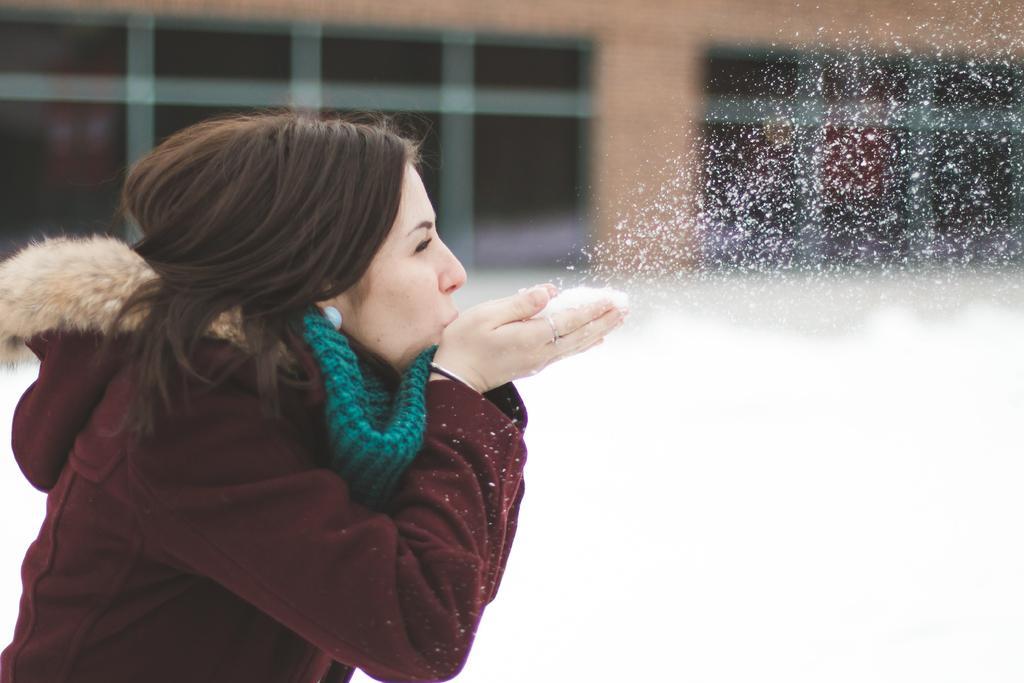Could you give a brief overview of what you see in this image? In this image there is a woman blowing the snow. In the background there is a building and there is snow on the surface. 